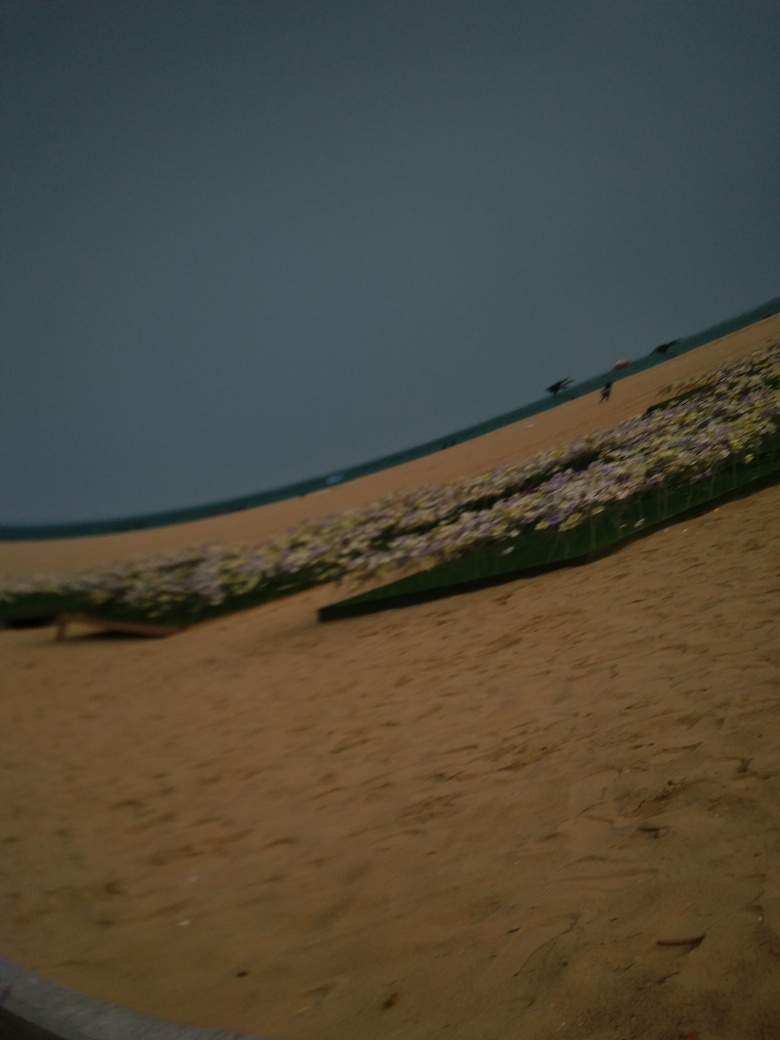Are there any human activities or constructions visible in this image? Although the image is not clear, what seems to be a patchwork of flowers suggests that the area might be maintained for recreational or decorative purposes. No distinct structures or people can be seen, hinting that this could be a more natural and less frequented part of a beach or park. 